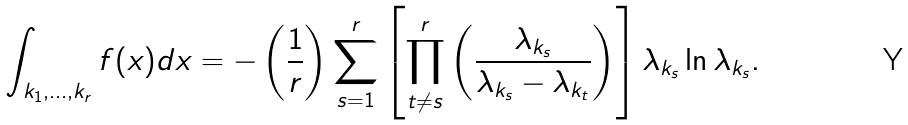Convert formula to latex. <formula><loc_0><loc_0><loc_500><loc_500>\int _ { k _ { 1 } , \dots , k _ { r } } f ( x ) d x = - \left ( \frac { 1 } { r } \right ) \sum _ { s = 1 } ^ { r } \left [ \prod _ { t \neq s } ^ { r } \left ( \frac { \lambda _ { k _ { s } } } { \lambda _ { k _ { s } } - \lambda _ { k _ { t } } } \right ) \right ] \lambda _ { k _ { s } } \ln \lambda _ { k _ { s } } .</formula> 